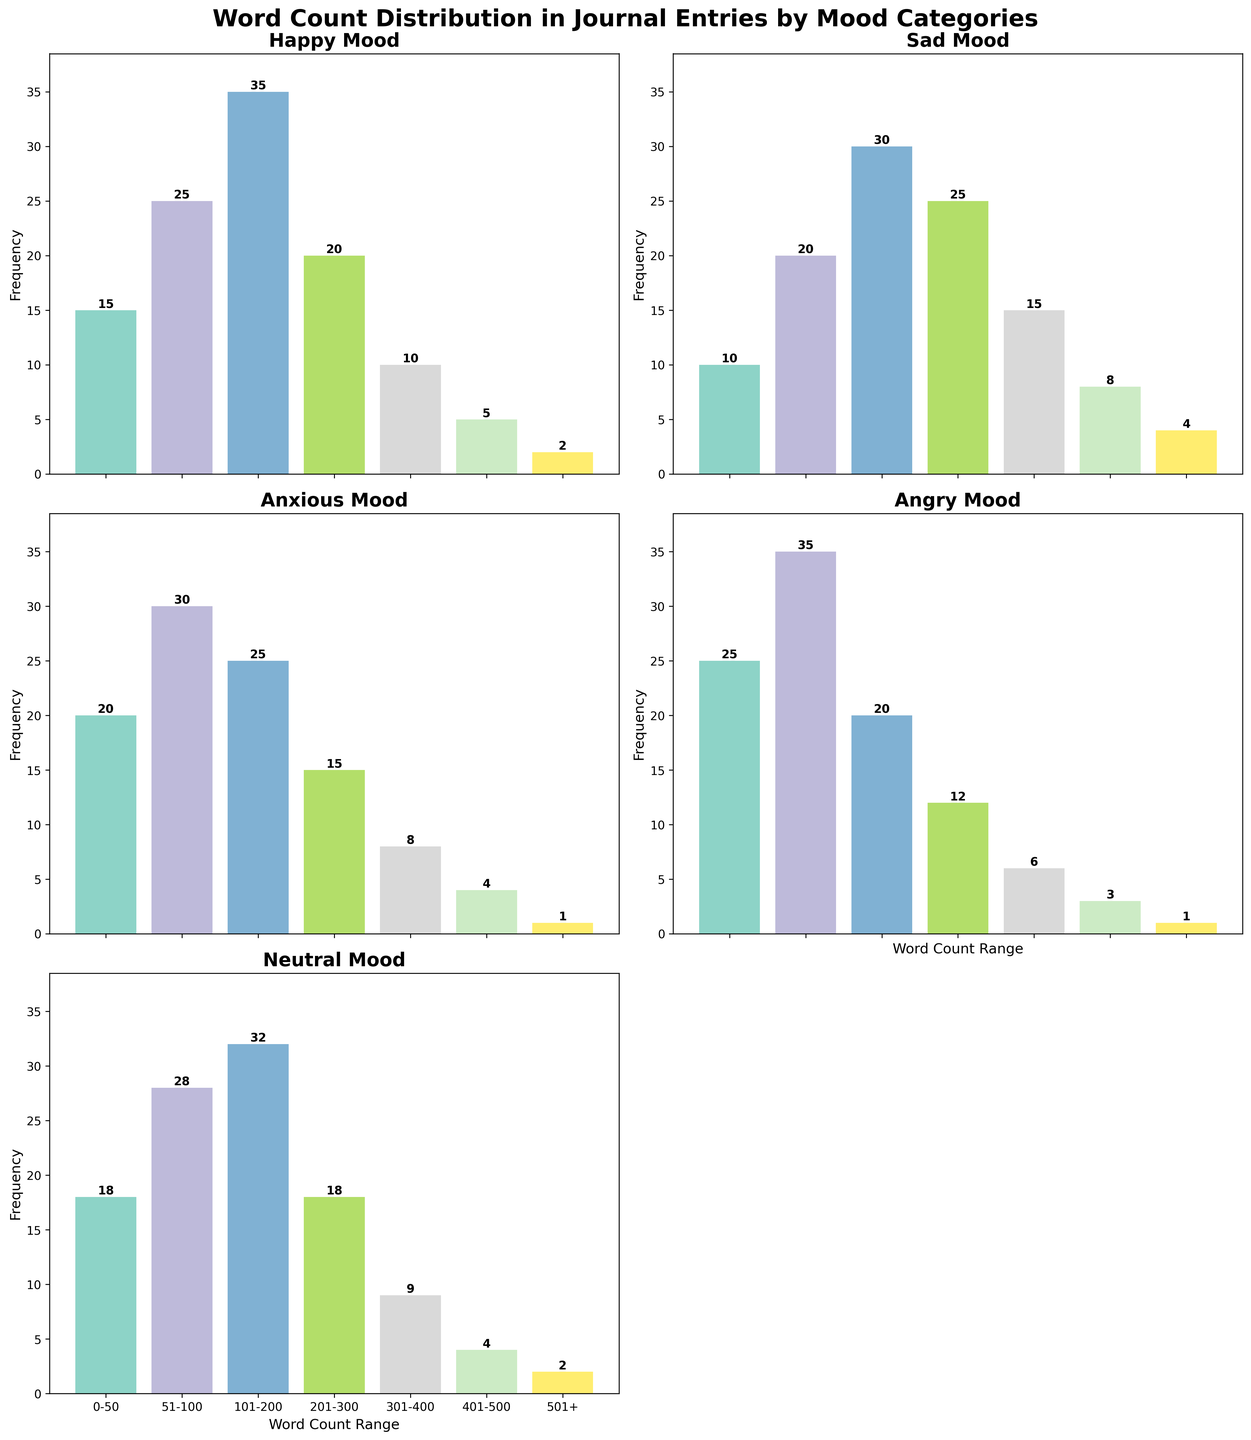Which mood category has the highest frequency for the 51-100 word count range? To find this, look at the height of the bars corresponding to the 51-100 word count range for each mood and compare. The "angry" mood has the tallest bar.
Answer: Angry What is the combined frequency of journal entries with word count over 400 across all moods? To determine this, sum the frequencies of the 401-500 and 501+ word count ranges for all moods. Calculate: Happy (5+2) + Sad (8+4) + Anxious (4+1) + Angry (3+1) + Neutral (4+2) = 27.
Answer: 27 Which mood has the smallest number of journal entries in the 0-50 word count range? Compare the bars for the 0-50 word count range in each subplot. The "sad" mood has the shortest bar in this range.
Answer: Sad How does the frequency distribution of journal entries differ between the "happy" and "anxious" moods? Review the subplots for "happy" and "anxious" moods and note the differences in bar heights for each word count range. The "happy" mood has fewer entries in the 0-50 range but more in the 101-200 and higher ranges compared to the "anxious" mood.
Answer: Happy mood has fewer 0-50 entries, more 101-200 and higher entries compared to Anxious mood What word count range has the highest frequency for the "neutral" mood, and what is that frequency? Examine the heights of the bars in the "neutral" mood subplot and identify the tallest one. The 101-200 word count range is the highest with a frequency of 32.
Answer: 101-200, 32 Are there any mood categories with the same frequency for the 501+ word count range? Compare the heights of the bars for the 501+ word count range in each subplot. Both "anxious" and "angry" moods have the same frequency of 1.
Answer: Anxious and Angry What is the total frequency of journal entries for the "sad" mood? Sum all the frequencies across the different word count ranges for the "sad" mood: 10+20+30+25+15+8+4 = 112.
Answer: 112 How do the frequencies of journal entries with word count in the 201-300 range compare between the "happy" and "neutral" moods? Compare the heights of the bars for the 201-300 word count range in the "happy" and "neutral" subplots. Both "happy" and "neutral" moods have a frequency of 20 and 18, respectively, so Happy is slightly higher.
Answer: Happy is slightly higher What is the difference in frequency between the "happy" and "angry" moods in the 51-100 word count range? Subtract the frequency of the 51-100 word count range for the "happy" mood from that of the "angry" mood: 35 - 25 = 10.
Answer: 10 Which mood has the most balanced distribution across the different word count ranges, suggesting a more even spread of journal entry lengths? By glancing at the bar heights for each mood, the "neutral" mood shows a more even distribution across different word count ranges compared to others.
Answer: Neutral 